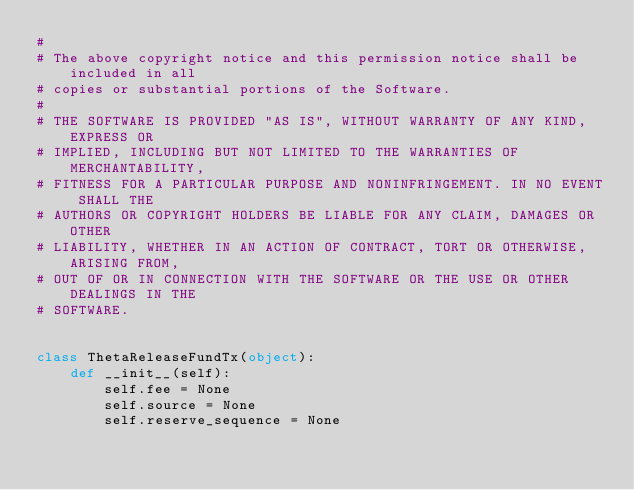Convert code to text. <code><loc_0><loc_0><loc_500><loc_500><_Python_>#
# The above copyright notice and this permission notice shall be included in all
# copies or substantial portions of the Software.
#
# THE SOFTWARE IS PROVIDED "AS IS", WITHOUT WARRANTY OF ANY KIND, EXPRESS OR
# IMPLIED, INCLUDING BUT NOT LIMITED TO THE WARRANTIES OF MERCHANTABILITY,
# FITNESS FOR A PARTICULAR PURPOSE AND NONINFRINGEMENT. IN NO EVENT SHALL THE
# AUTHORS OR COPYRIGHT HOLDERS BE LIABLE FOR ANY CLAIM, DAMAGES OR OTHER
# LIABILITY, WHETHER IN AN ACTION OF CONTRACT, TORT OR OTHERWISE, ARISING FROM,
# OUT OF OR IN CONNECTION WITH THE SOFTWARE OR THE USE OR OTHER DEALINGS IN THE
# SOFTWARE.


class ThetaReleaseFundTx(object):
    def __init__(self):
        self.fee = None
        self.source = None
        self.reserve_sequence = None</code> 